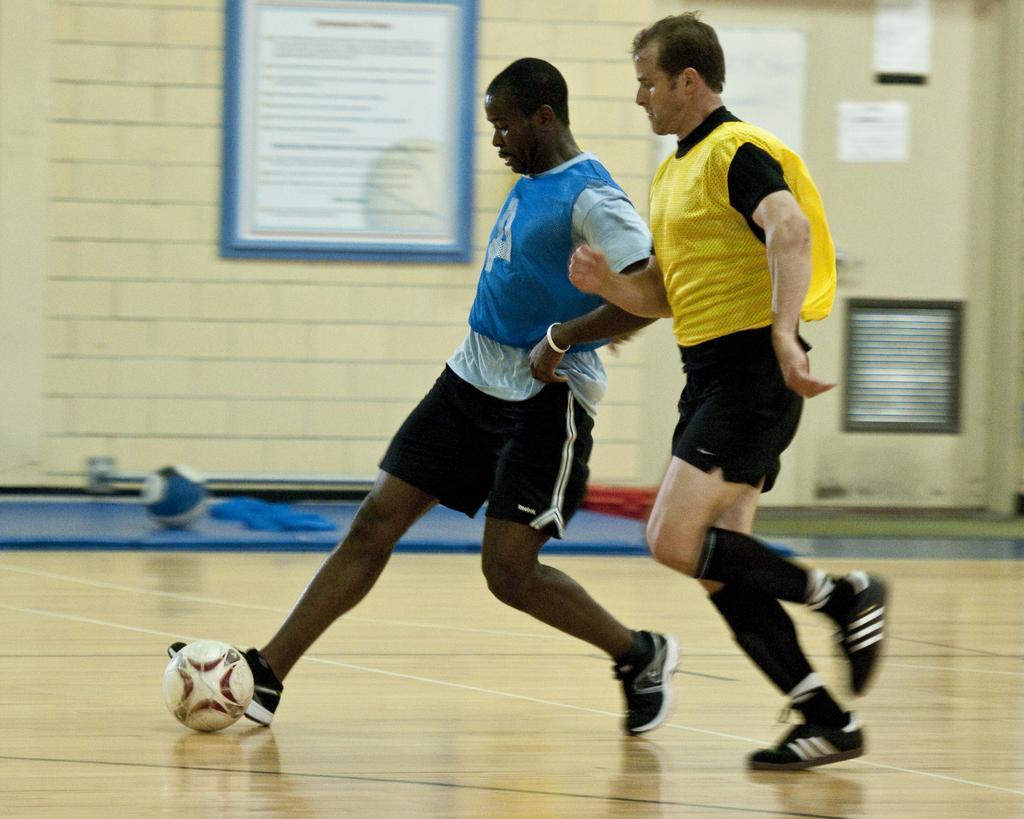In one or two sentences, can you explain what this image depicts? Here we can see two persons are playing with a ball. In the background we can see a wall and frames. 